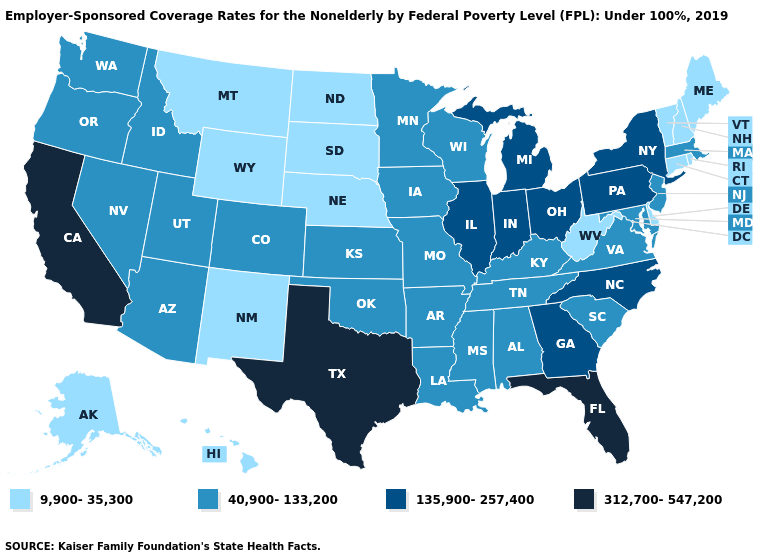Among the states that border Wyoming , which have the highest value?
Give a very brief answer. Colorado, Idaho, Utah. What is the lowest value in the West?
Concise answer only. 9,900-35,300. What is the highest value in the USA?
Concise answer only. 312,700-547,200. Among the states that border Wisconsin , which have the highest value?
Concise answer only. Illinois, Michigan. What is the highest value in the Northeast ?
Quick response, please. 135,900-257,400. Does Delaware have the highest value in the South?
Answer briefly. No. Does Delaware have the lowest value in the USA?
Quick response, please. Yes. What is the lowest value in the USA?
Keep it brief. 9,900-35,300. Name the states that have a value in the range 9,900-35,300?
Quick response, please. Alaska, Connecticut, Delaware, Hawaii, Maine, Montana, Nebraska, New Hampshire, New Mexico, North Dakota, Rhode Island, South Dakota, Vermont, West Virginia, Wyoming. Which states have the highest value in the USA?
Give a very brief answer. California, Florida, Texas. Among the states that border Washington , which have the highest value?
Concise answer only. Idaho, Oregon. Among the states that border Delaware , does Pennsylvania have the lowest value?
Concise answer only. No. What is the lowest value in states that border Pennsylvania?
Give a very brief answer. 9,900-35,300. Does the map have missing data?
Be succinct. No. Is the legend a continuous bar?
Be succinct. No. 